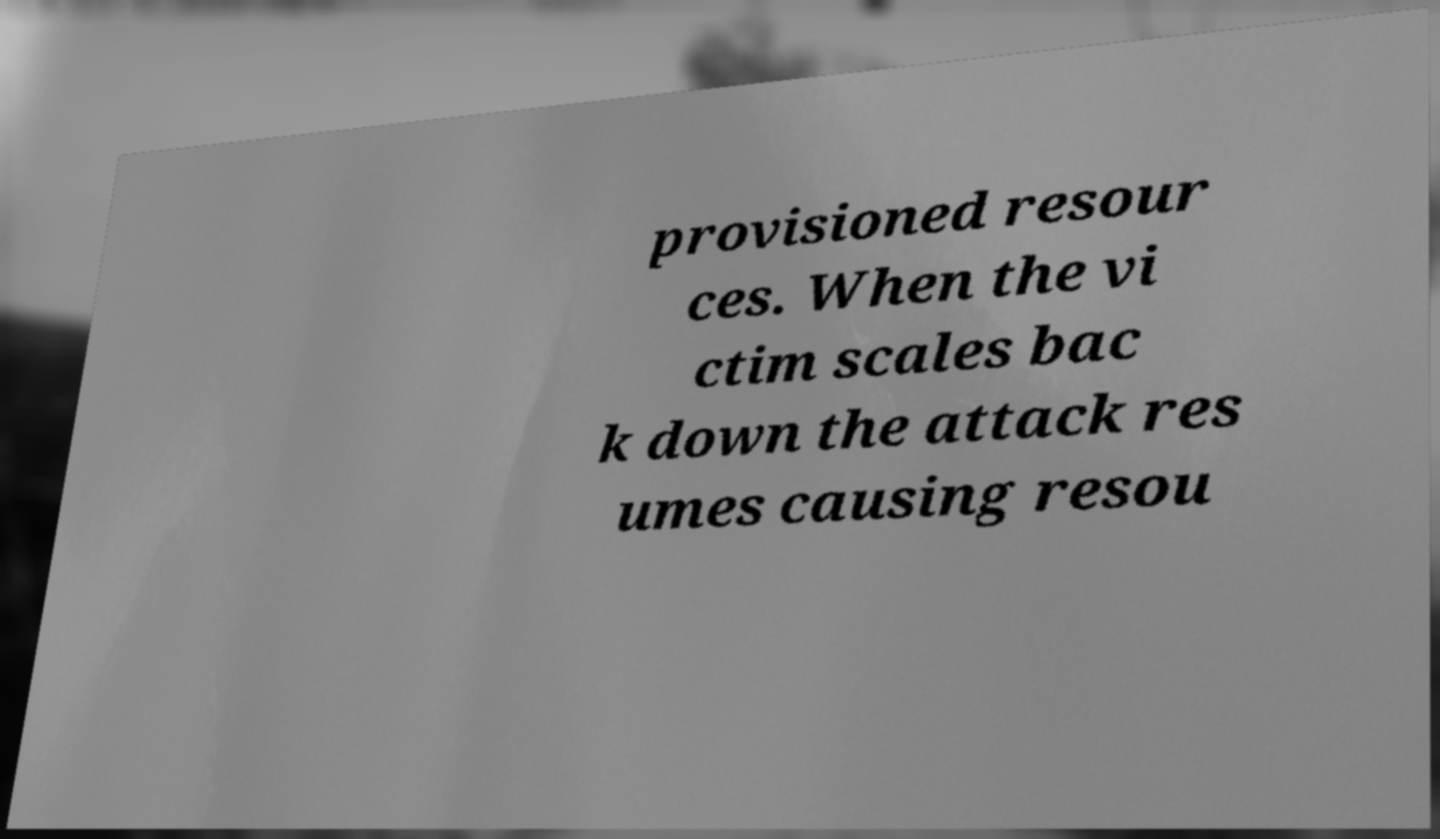For documentation purposes, I need the text within this image transcribed. Could you provide that? provisioned resour ces. When the vi ctim scales bac k down the attack res umes causing resou 